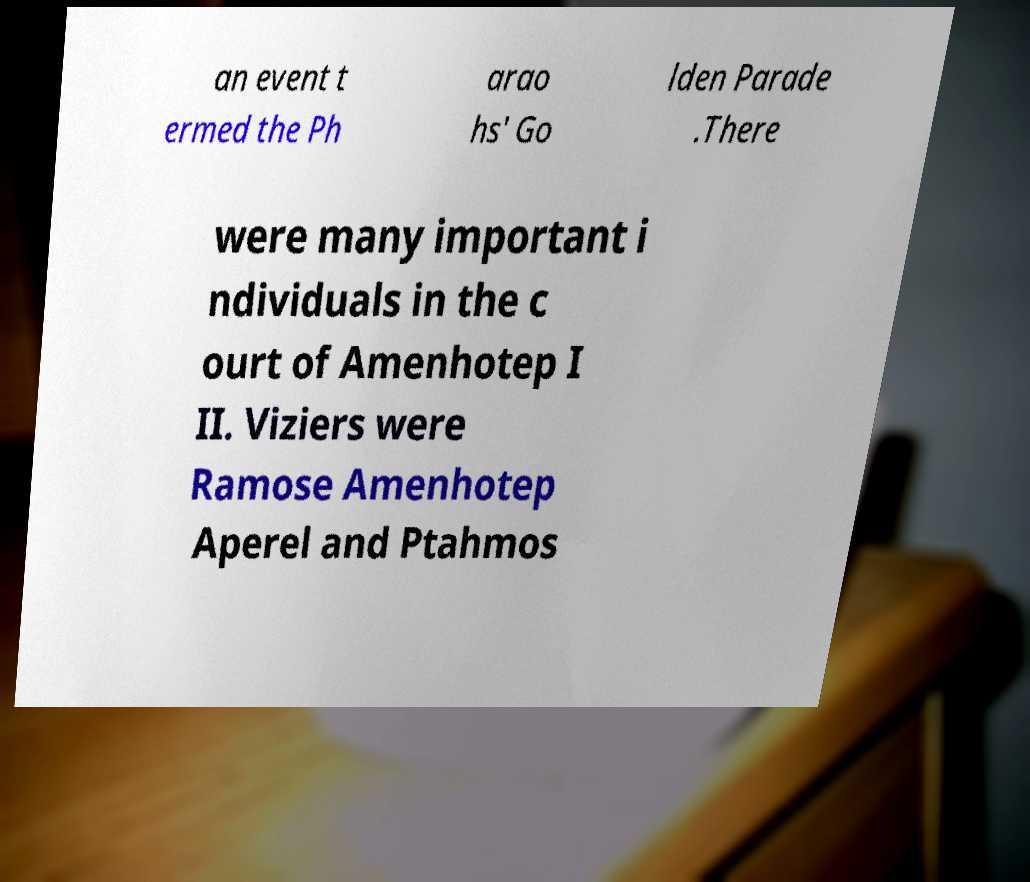I need the written content from this picture converted into text. Can you do that? an event t ermed the Ph arao hs' Go lden Parade .There were many important i ndividuals in the c ourt of Amenhotep I II. Viziers were Ramose Amenhotep Aperel and Ptahmos 